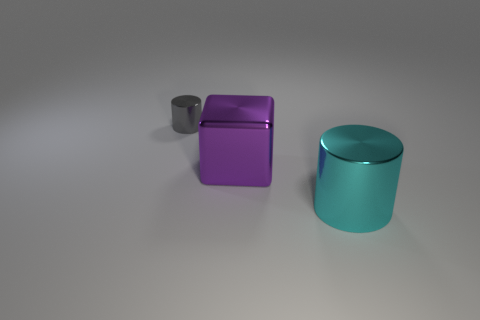Add 2 cyan metallic cylinders. How many objects exist? 5 Subtract all cylinders. How many objects are left? 1 Subtract all purple objects. Subtract all cyan cylinders. How many objects are left? 1 Add 1 metallic things. How many metallic things are left? 4 Add 1 metallic spheres. How many metallic spheres exist? 1 Subtract 1 purple cubes. How many objects are left? 2 